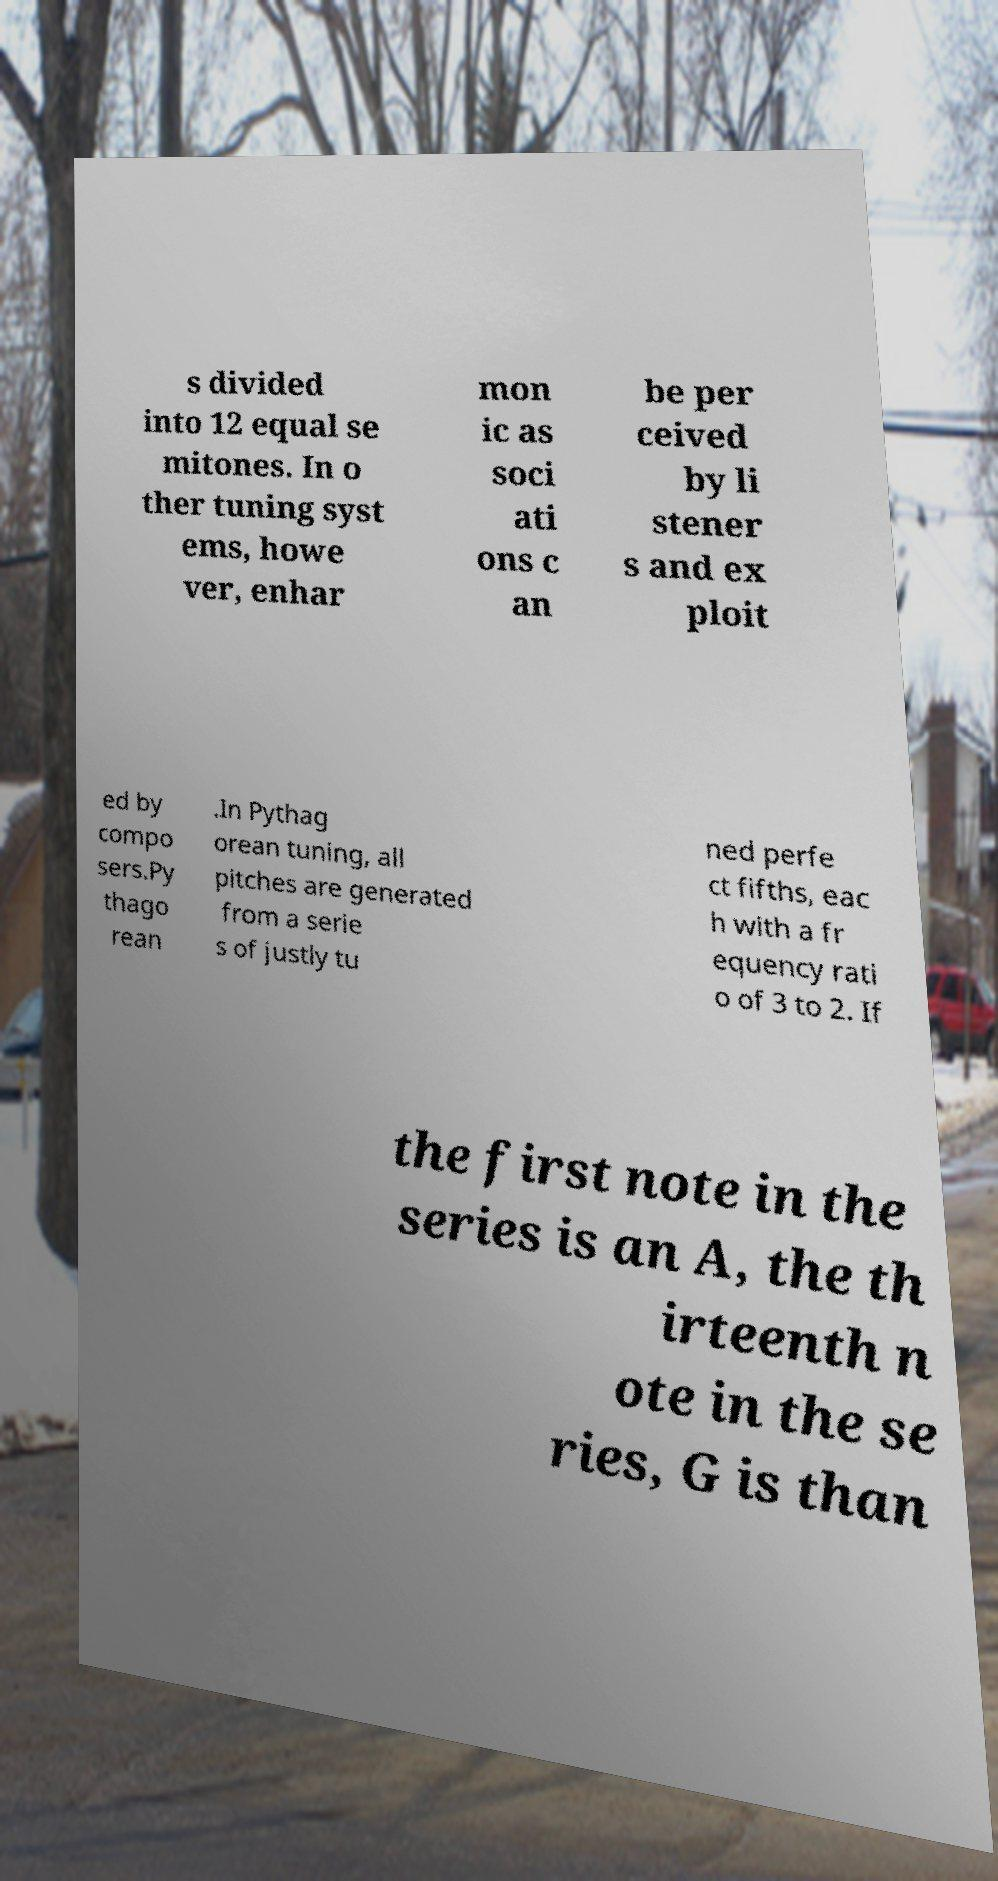Please read and relay the text visible in this image. What does it say? s divided into 12 equal se mitones. In o ther tuning syst ems, howe ver, enhar mon ic as soci ati ons c an be per ceived by li stener s and ex ploit ed by compo sers.Py thago rean .In Pythag orean tuning, all pitches are generated from a serie s of justly tu ned perfe ct fifths, eac h with a fr equency rati o of 3 to 2. If the first note in the series is an A, the th irteenth n ote in the se ries, G is than 